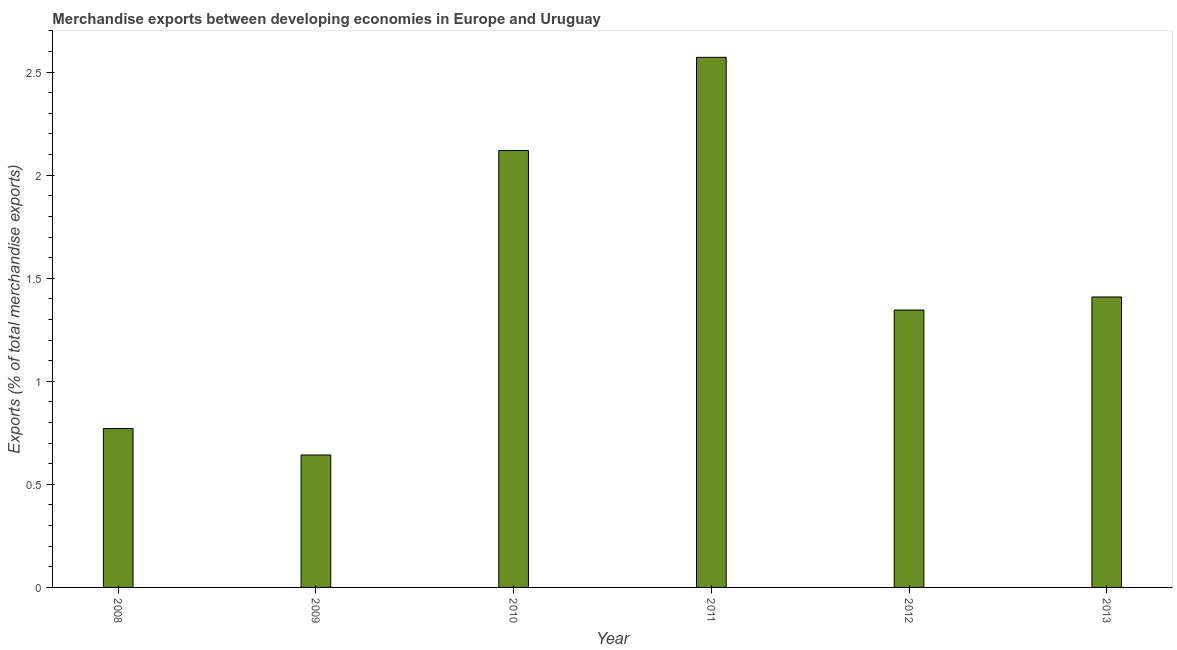What is the title of the graph?
Ensure brevity in your answer.  Merchandise exports between developing economies in Europe and Uruguay. What is the label or title of the X-axis?
Your answer should be compact. Year. What is the label or title of the Y-axis?
Offer a very short reply. Exports (% of total merchandise exports). What is the merchandise exports in 2008?
Keep it short and to the point. 0.77. Across all years, what is the maximum merchandise exports?
Offer a very short reply. 2.57. Across all years, what is the minimum merchandise exports?
Give a very brief answer. 0.64. In which year was the merchandise exports maximum?
Offer a terse response. 2011. In which year was the merchandise exports minimum?
Your answer should be very brief. 2009. What is the sum of the merchandise exports?
Your answer should be compact. 8.86. What is the difference between the merchandise exports in 2009 and 2011?
Provide a succinct answer. -1.93. What is the average merchandise exports per year?
Offer a terse response. 1.48. What is the median merchandise exports?
Provide a succinct answer. 1.38. What is the ratio of the merchandise exports in 2009 to that in 2013?
Offer a very short reply. 0.46. What is the difference between the highest and the second highest merchandise exports?
Offer a terse response. 0.45. What is the difference between the highest and the lowest merchandise exports?
Offer a terse response. 1.93. Are all the bars in the graph horizontal?
Your answer should be very brief. No. What is the Exports (% of total merchandise exports) of 2008?
Keep it short and to the point. 0.77. What is the Exports (% of total merchandise exports) of 2009?
Ensure brevity in your answer.  0.64. What is the Exports (% of total merchandise exports) in 2010?
Offer a terse response. 2.12. What is the Exports (% of total merchandise exports) in 2011?
Make the answer very short. 2.57. What is the Exports (% of total merchandise exports) of 2012?
Offer a very short reply. 1.35. What is the Exports (% of total merchandise exports) of 2013?
Provide a short and direct response. 1.41. What is the difference between the Exports (% of total merchandise exports) in 2008 and 2009?
Offer a terse response. 0.13. What is the difference between the Exports (% of total merchandise exports) in 2008 and 2010?
Offer a terse response. -1.35. What is the difference between the Exports (% of total merchandise exports) in 2008 and 2011?
Your answer should be very brief. -1.8. What is the difference between the Exports (% of total merchandise exports) in 2008 and 2012?
Keep it short and to the point. -0.57. What is the difference between the Exports (% of total merchandise exports) in 2008 and 2013?
Keep it short and to the point. -0.64. What is the difference between the Exports (% of total merchandise exports) in 2009 and 2010?
Give a very brief answer. -1.48. What is the difference between the Exports (% of total merchandise exports) in 2009 and 2011?
Give a very brief answer. -1.93. What is the difference between the Exports (% of total merchandise exports) in 2009 and 2012?
Provide a succinct answer. -0.7. What is the difference between the Exports (% of total merchandise exports) in 2009 and 2013?
Your answer should be compact. -0.77. What is the difference between the Exports (% of total merchandise exports) in 2010 and 2011?
Give a very brief answer. -0.45. What is the difference between the Exports (% of total merchandise exports) in 2010 and 2012?
Offer a very short reply. 0.77. What is the difference between the Exports (% of total merchandise exports) in 2010 and 2013?
Offer a very short reply. 0.71. What is the difference between the Exports (% of total merchandise exports) in 2011 and 2012?
Provide a succinct answer. 1.23. What is the difference between the Exports (% of total merchandise exports) in 2011 and 2013?
Make the answer very short. 1.16. What is the difference between the Exports (% of total merchandise exports) in 2012 and 2013?
Provide a short and direct response. -0.06. What is the ratio of the Exports (% of total merchandise exports) in 2008 to that in 2010?
Offer a very short reply. 0.36. What is the ratio of the Exports (% of total merchandise exports) in 2008 to that in 2011?
Your response must be concise. 0.3. What is the ratio of the Exports (% of total merchandise exports) in 2008 to that in 2012?
Ensure brevity in your answer.  0.57. What is the ratio of the Exports (% of total merchandise exports) in 2008 to that in 2013?
Ensure brevity in your answer.  0.55. What is the ratio of the Exports (% of total merchandise exports) in 2009 to that in 2010?
Give a very brief answer. 0.3. What is the ratio of the Exports (% of total merchandise exports) in 2009 to that in 2011?
Provide a succinct answer. 0.25. What is the ratio of the Exports (% of total merchandise exports) in 2009 to that in 2012?
Offer a very short reply. 0.48. What is the ratio of the Exports (% of total merchandise exports) in 2009 to that in 2013?
Ensure brevity in your answer.  0.46. What is the ratio of the Exports (% of total merchandise exports) in 2010 to that in 2011?
Your response must be concise. 0.82. What is the ratio of the Exports (% of total merchandise exports) in 2010 to that in 2012?
Provide a short and direct response. 1.57. What is the ratio of the Exports (% of total merchandise exports) in 2010 to that in 2013?
Make the answer very short. 1.5. What is the ratio of the Exports (% of total merchandise exports) in 2011 to that in 2012?
Give a very brief answer. 1.91. What is the ratio of the Exports (% of total merchandise exports) in 2011 to that in 2013?
Give a very brief answer. 1.82. What is the ratio of the Exports (% of total merchandise exports) in 2012 to that in 2013?
Your answer should be compact. 0.95. 